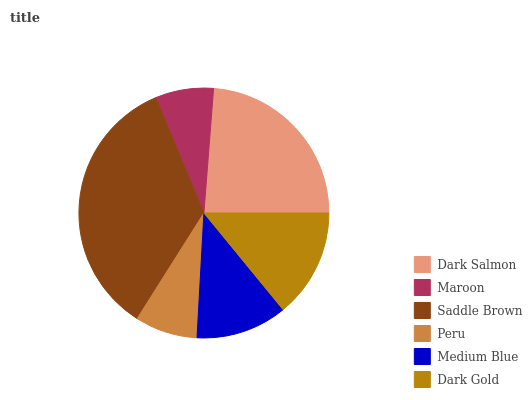Is Maroon the minimum?
Answer yes or no. Yes. Is Saddle Brown the maximum?
Answer yes or no. Yes. Is Saddle Brown the minimum?
Answer yes or no. No. Is Maroon the maximum?
Answer yes or no. No. Is Saddle Brown greater than Maroon?
Answer yes or no. Yes. Is Maroon less than Saddle Brown?
Answer yes or no. Yes. Is Maroon greater than Saddle Brown?
Answer yes or no. No. Is Saddle Brown less than Maroon?
Answer yes or no. No. Is Dark Gold the high median?
Answer yes or no. Yes. Is Medium Blue the low median?
Answer yes or no. Yes. Is Peru the high median?
Answer yes or no. No. Is Peru the low median?
Answer yes or no. No. 